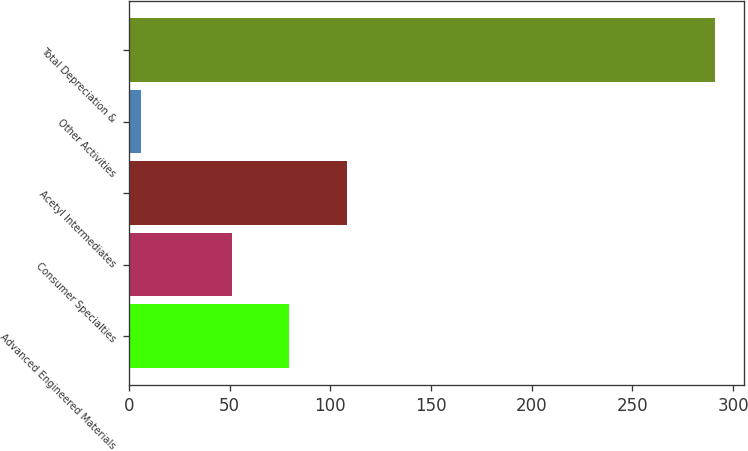Convert chart to OTSL. <chart><loc_0><loc_0><loc_500><loc_500><bar_chart><fcel>Advanced Engineered Materials<fcel>Consumer Specialties<fcel>Acetyl Intermediates<fcel>Other Activities<fcel>Total Depreciation &<nl><fcel>79.5<fcel>51<fcel>108<fcel>6<fcel>291<nl></chart> 